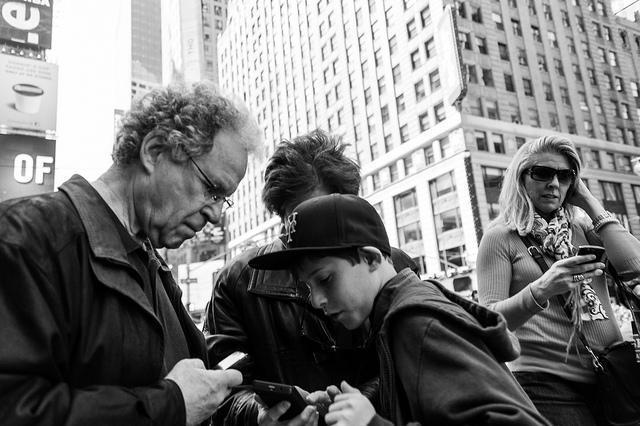How many people are shown?
Give a very brief answer. 4. How many people are there?
Give a very brief answer. 4. 